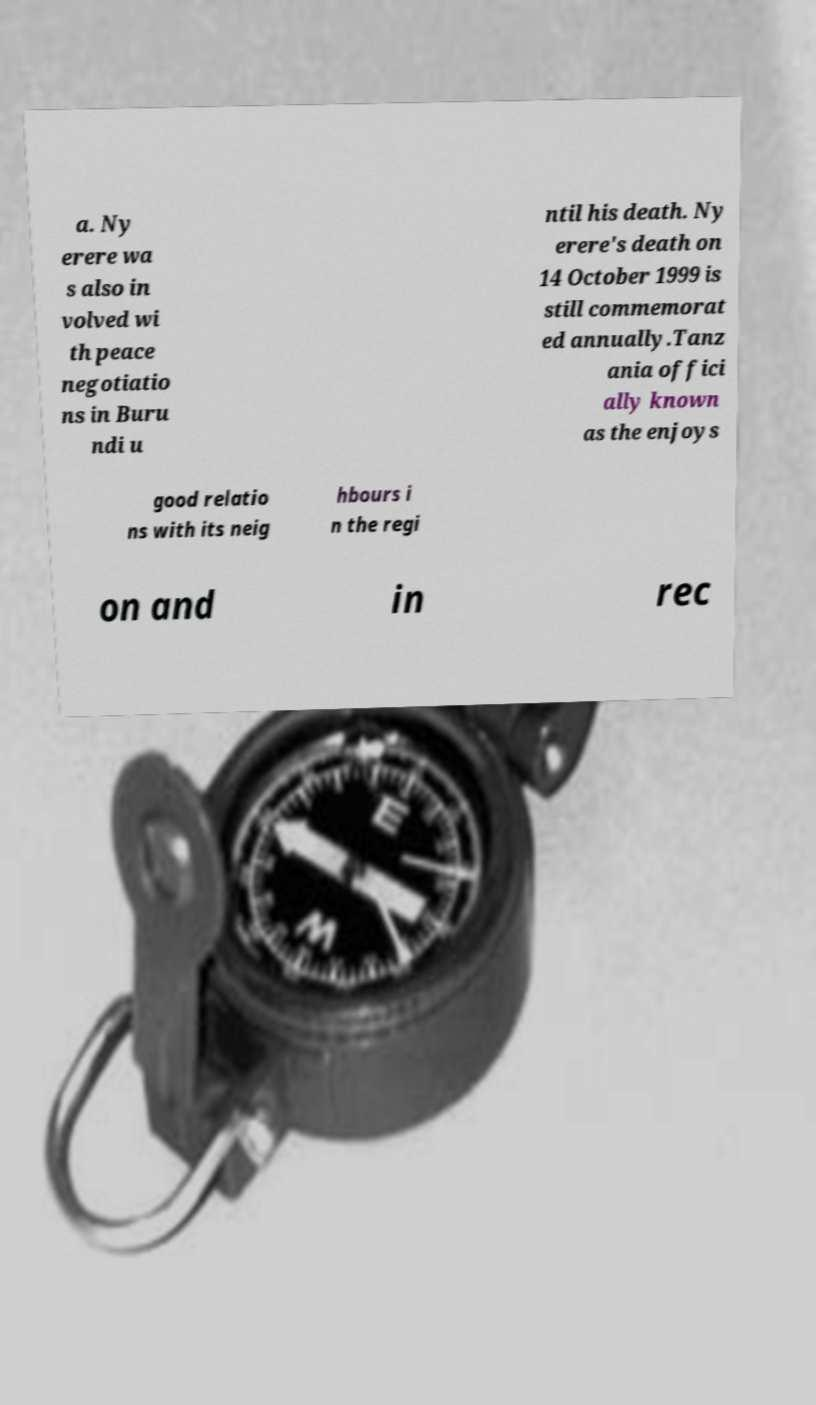Could you assist in decoding the text presented in this image and type it out clearly? a. Ny erere wa s also in volved wi th peace negotiatio ns in Buru ndi u ntil his death. Ny erere's death on 14 October 1999 is still commemorat ed annually.Tanz ania offici ally known as the enjoys good relatio ns with its neig hbours i n the regi on and in rec 